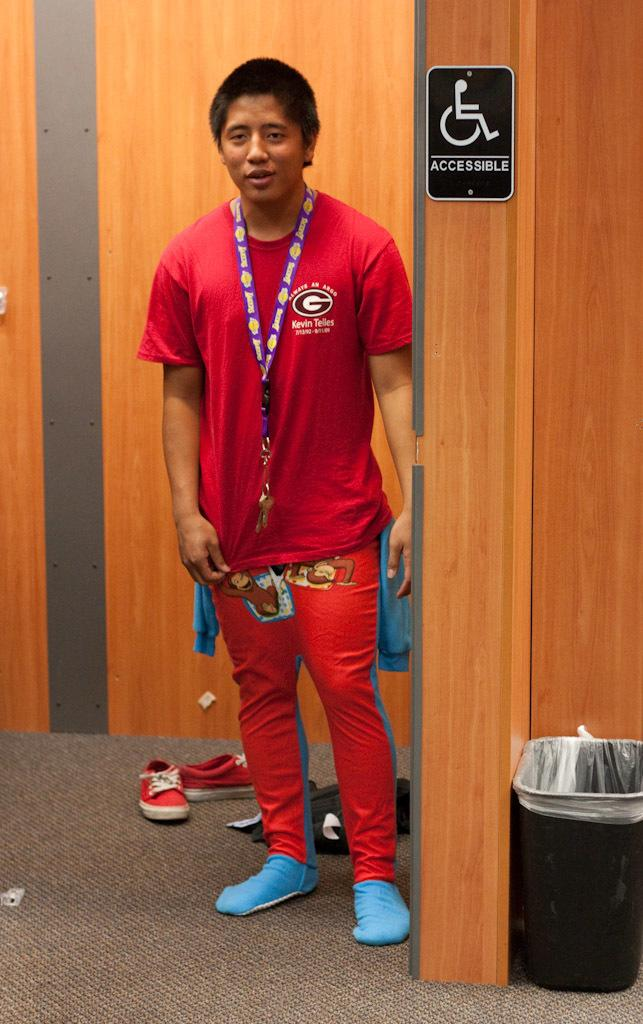<image>
Create a compact narrative representing the image presented. a man in a red outfit in a changing room saying Accessible on it 